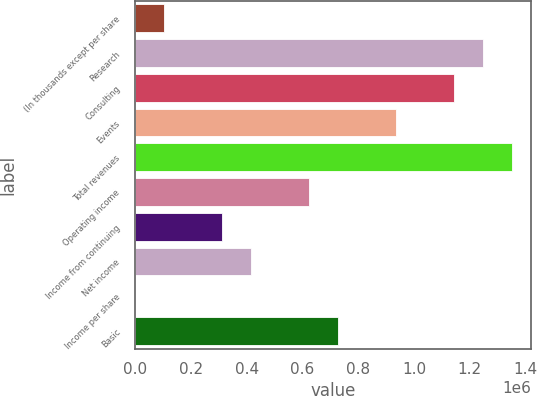Convert chart. <chart><loc_0><loc_0><loc_500><loc_500><bar_chart><fcel>(In thousands except per share<fcel>Research<fcel>Consulting<fcel>Events<fcel>Total revenues<fcel>Operating income<fcel>Income from continuing<fcel>Net income<fcel>Income per share<fcel>Basic<nl><fcel>103980<fcel>1.24775e+06<fcel>1.14377e+06<fcel>935814<fcel>1.35173e+06<fcel>623876<fcel>311938<fcel>415918<fcel>0.51<fcel>727855<nl></chart> 